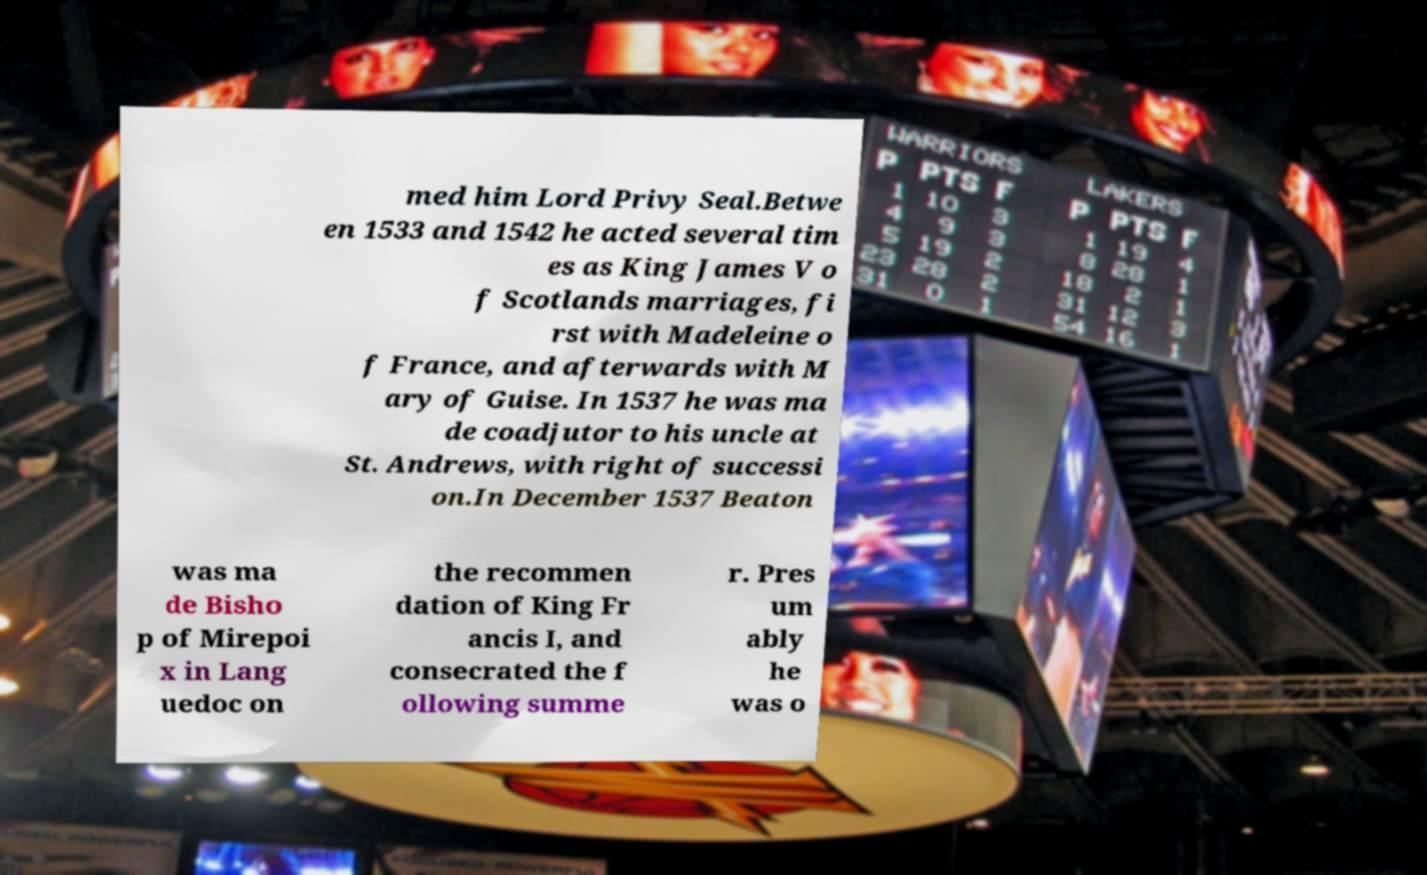Please identify and transcribe the text found in this image. med him Lord Privy Seal.Betwe en 1533 and 1542 he acted several tim es as King James V o f Scotlands marriages, fi rst with Madeleine o f France, and afterwards with M ary of Guise. In 1537 he was ma de coadjutor to his uncle at St. Andrews, with right of successi on.In December 1537 Beaton was ma de Bisho p of Mirepoi x in Lang uedoc on the recommen dation of King Fr ancis I, and consecrated the f ollowing summe r. Pres um ably he was o 